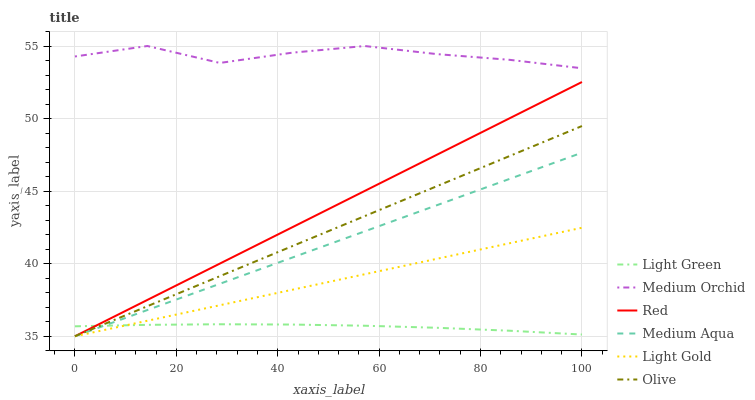Does Light Green have the minimum area under the curve?
Answer yes or no. Yes. Does Medium Orchid have the maximum area under the curve?
Answer yes or no. Yes. Does Medium Aqua have the minimum area under the curve?
Answer yes or no. No. Does Medium Aqua have the maximum area under the curve?
Answer yes or no. No. Is Medium Aqua the smoothest?
Answer yes or no. Yes. Is Medium Orchid the roughest?
Answer yes or no. Yes. Is Light Green the smoothest?
Answer yes or no. No. Is Light Green the roughest?
Answer yes or no. No. Does Light Green have the lowest value?
Answer yes or no. No. Does Medium Orchid have the highest value?
Answer yes or no. Yes. Does Medium Aqua have the highest value?
Answer yes or no. No. Is Light Gold less than Medium Orchid?
Answer yes or no. Yes. Is Medium Orchid greater than Red?
Answer yes or no. Yes. Does Olive intersect Light Gold?
Answer yes or no. Yes. Is Olive less than Light Gold?
Answer yes or no. No. Is Olive greater than Light Gold?
Answer yes or no. No. Does Light Gold intersect Medium Orchid?
Answer yes or no. No. 